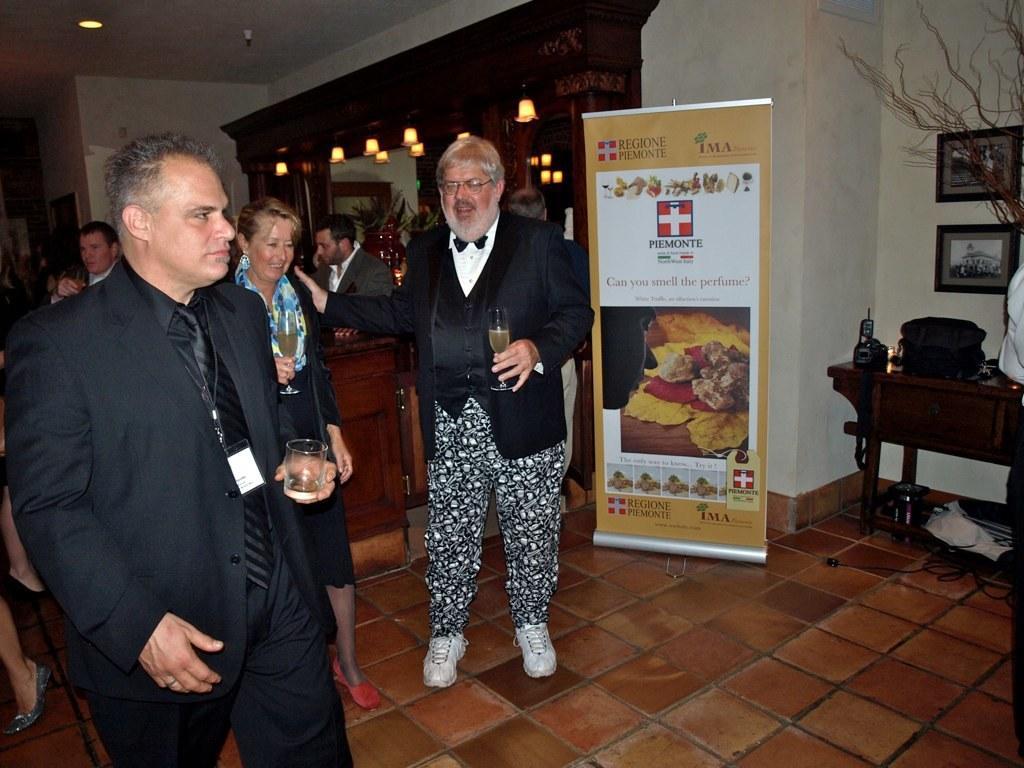Can you describe this image briefly? There are men standing holding a glass of wine and beside them there is a table and backpack on it and photo frames above that. 